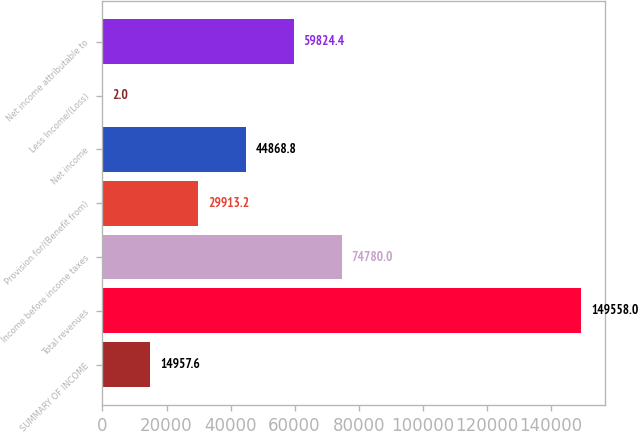<chart> <loc_0><loc_0><loc_500><loc_500><bar_chart><fcel>SUMMARY OF INCOME<fcel>Total revenues<fcel>Income before income taxes<fcel>Provision for/(Benefit from)<fcel>Net income<fcel>Less Income/(Loss)<fcel>Net income attributable to<nl><fcel>14957.6<fcel>149558<fcel>74780<fcel>29913.2<fcel>44868.8<fcel>2<fcel>59824.4<nl></chart> 